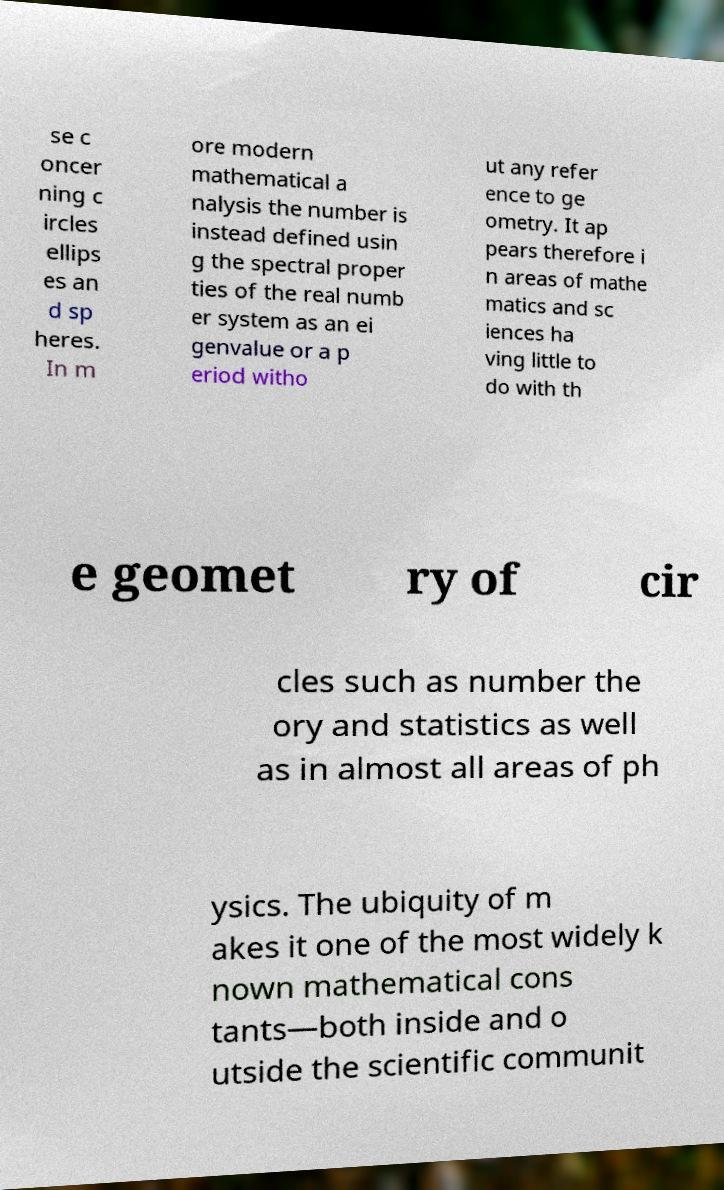What messages or text are displayed in this image? I need them in a readable, typed format. se c oncer ning c ircles ellips es an d sp heres. In m ore modern mathematical a nalysis the number is instead defined usin g the spectral proper ties of the real numb er system as an ei genvalue or a p eriod witho ut any refer ence to ge ometry. It ap pears therefore i n areas of mathe matics and sc iences ha ving little to do with th e geomet ry of cir cles such as number the ory and statistics as well as in almost all areas of ph ysics. The ubiquity of m akes it one of the most widely k nown mathematical cons tants—both inside and o utside the scientific communit 